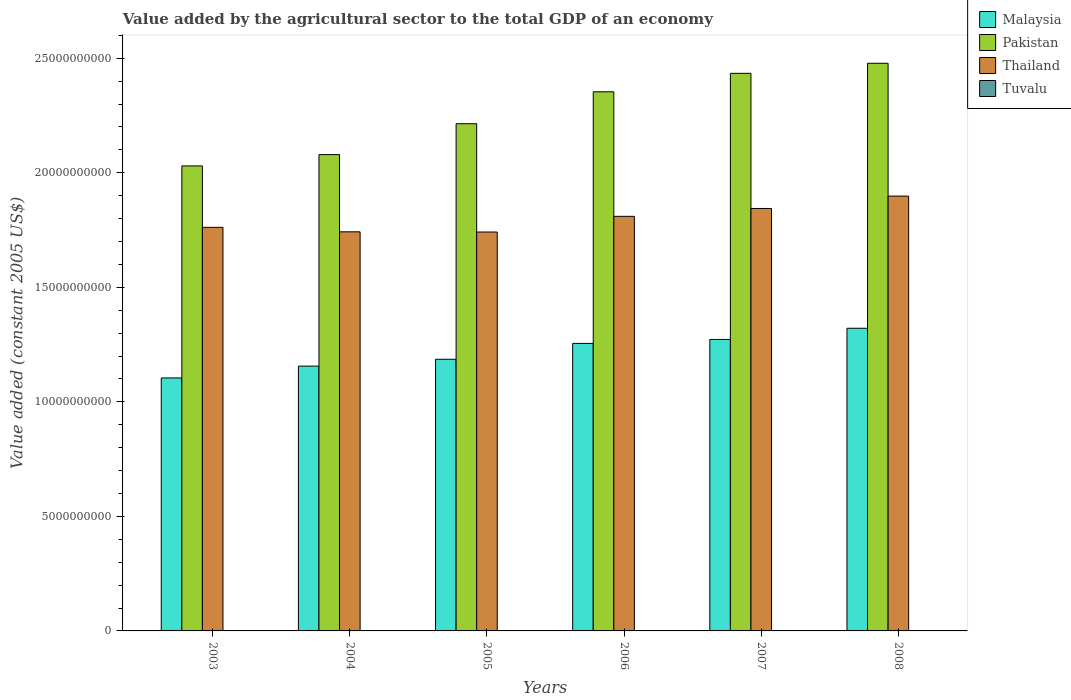How many different coloured bars are there?
Offer a terse response. 4. How many groups of bars are there?
Your answer should be very brief. 6. Are the number of bars per tick equal to the number of legend labels?
Offer a very short reply. Yes. What is the value added by the agricultural sector in Pakistan in 2005?
Make the answer very short. 2.21e+1. Across all years, what is the maximum value added by the agricultural sector in Thailand?
Give a very brief answer. 1.90e+1. Across all years, what is the minimum value added by the agricultural sector in Pakistan?
Offer a terse response. 2.03e+1. In which year was the value added by the agricultural sector in Thailand maximum?
Your response must be concise. 2008. In which year was the value added by the agricultural sector in Malaysia minimum?
Your answer should be compact. 2003. What is the total value added by the agricultural sector in Thailand in the graph?
Keep it short and to the point. 1.08e+11. What is the difference between the value added by the agricultural sector in Tuvalu in 2003 and that in 2006?
Your answer should be compact. -7.79e+05. What is the difference between the value added by the agricultural sector in Tuvalu in 2007 and the value added by the agricultural sector in Pakistan in 2005?
Offer a terse response. -2.21e+1. What is the average value added by the agricultural sector in Malaysia per year?
Keep it short and to the point. 1.22e+1. In the year 2005, what is the difference between the value added by the agricultural sector in Pakistan and value added by the agricultural sector in Tuvalu?
Your response must be concise. 2.21e+1. In how many years, is the value added by the agricultural sector in Tuvalu greater than 13000000000 US$?
Ensure brevity in your answer.  0. What is the ratio of the value added by the agricultural sector in Tuvalu in 2006 to that in 2008?
Your answer should be compact. 0.98. What is the difference between the highest and the second highest value added by the agricultural sector in Malaysia?
Your answer should be compact. 4.88e+08. What is the difference between the highest and the lowest value added by the agricultural sector in Malaysia?
Provide a succinct answer. 2.17e+09. In how many years, is the value added by the agricultural sector in Tuvalu greater than the average value added by the agricultural sector in Tuvalu taken over all years?
Give a very brief answer. 3. Is the sum of the value added by the agricultural sector in Thailand in 2003 and 2008 greater than the maximum value added by the agricultural sector in Pakistan across all years?
Give a very brief answer. Yes. What does the 1st bar from the left in 2005 represents?
Offer a very short reply. Malaysia. What does the 4th bar from the right in 2005 represents?
Your answer should be compact. Malaysia. Is it the case that in every year, the sum of the value added by the agricultural sector in Malaysia and value added by the agricultural sector in Tuvalu is greater than the value added by the agricultural sector in Thailand?
Keep it short and to the point. No. Are all the bars in the graph horizontal?
Provide a succinct answer. No. Does the graph contain any zero values?
Provide a short and direct response. No. Does the graph contain grids?
Offer a very short reply. No. What is the title of the graph?
Offer a very short reply. Value added by the agricultural sector to the total GDP of an economy. Does "Ecuador" appear as one of the legend labels in the graph?
Give a very brief answer. No. What is the label or title of the X-axis?
Give a very brief answer. Years. What is the label or title of the Y-axis?
Provide a short and direct response. Value added (constant 2005 US$). What is the Value added (constant 2005 US$) in Malaysia in 2003?
Offer a terse response. 1.10e+1. What is the Value added (constant 2005 US$) of Pakistan in 2003?
Provide a succinct answer. 2.03e+1. What is the Value added (constant 2005 US$) in Thailand in 2003?
Make the answer very short. 1.76e+1. What is the Value added (constant 2005 US$) in Tuvalu in 2003?
Your response must be concise. 4.22e+06. What is the Value added (constant 2005 US$) of Malaysia in 2004?
Your answer should be compact. 1.16e+1. What is the Value added (constant 2005 US$) of Pakistan in 2004?
Provide a short and direct response. 2.08e+1. What is the Value added (constant 2005 US$) in Thailand in 2004?
Your answer should be very brief. 1.74e+1. What is the Value added (constant 2005 US$) of Tuvalu in 2004?
Provide a succinct answer. 4.41e+06. What is the Value added (constant 2005 US$) in Malaysia in 2005?
Your answer should be compact. 1.19e+1. What is the Value added (constant 2005 US$) of Pakistan in 2005?
Your answer should be very brief. 2.21e+1. What is the Value added (constant 2005 US$) in Thailand in 2005?
Ensure brevity in your answer.  1.74e+1. What is the Value added (constant 2005 US$) of Tuvalu in 2005?
Give a very brief answer. 4.45e+06. What is the Value added (constant 2005 US$) in Malaysia in 2006?
Provide a short and direct response. 1.26e+1. What is the Value added (constant 2005 US$) in Pakistan in 2006?
Your answer should be very brief. 2.35e+1. What is the Value added (constant 2005 US$) of Thailand in 2006?
Give a very brief answer. 1.81e+1. What is the Value added (constant 2005 US$) in Tuvalu in 2006?
Your answer should be compact. 5.00e+06. What is the Value added (constant 2005 US$) in Malaysia in 2007?
Provide a short and direct response. 1.27e+1. What is the Value added (constant 2005 US$) of Pakistan in 2007?
Your answer should be very brief. 2.43e+1. What is the Value added (constant 2005 US$) in Thailand in 2007?
Offer a very short reply. 1.84e+1. What is the Value added (constant 2005 US$) in Tuvalu in 2007?
Your response must be concise. 5.06e+06. What is the Value added (constant 2005 US$) of Malaysia in 2008?
Provide a short and direct response. 1.32e+1. What is the Value added (constant 2005 US$) of Pakistan in 2008?
Provide a succinct answer. 2.48e+1. What is the Value added (constant 2005 US$) of Thailand in 2008?
Your response must be concise. 1.90e+1. What is the Value added (constant 2005 US$) in Tuvalu in 2008?
Your answer should be compact. 5.10e+06. Across all years, what is the maximum Value added (constant 2005 US$) of Malaysia?
Provide a succinct answer. 1.32e+1. Across all years, what is the maximum Value added (constant 2005 US$) of Pakistan?
Offer a terse response. 2.48e+1. Across all years, what is the maximum Value added (constant 2005 US$) in Thailand?
Offer a terse response. 1.90e+1. Across all years, what is the maximum Value added (constant 2005 US$) of Tuvalu?
Make the answer very short. 5.10e+06. Across all years, what is the minimum Value added (constant 2005 US$) of Malaysia?
Provide a short and direct response. 1.10e+1. Across all years, what is the minimum Value added (constant 2005 US$) in Pakistan?
Your answer should be compact. 2.03e+1. Across all years, what is the minimum Value added (constant 2005 US$) of Thailand?
Ensure brevity in your answer.  1.74e+1. Across all years, what is the minimum Value added (constant 2005 US$) in Tuvalu?
Your response must be concise. 4.22e+06. What is the total Value added (constant 2005 US$) in Malaysia in the graph?
Your answer should be very brief. 7.29e+1. What is the total Value added (constant 2005 US$) of Pakistan in the graph?
Your answer should be compact. 1.36e+11. What is the total Value added (constant 2005 US$) of Thailand in the graph?
Your answer should be very brief. 1.08e+11. What is the total Value added (constant 2005 US$) of Tuvalu in the graph?
Offer a very short reply. 2.82e+07. What is the difference between the Value added (constant 2005 US$) of Malaysia in 2003 and that in 2004?
Ensure brevity in your answer.  -5.16e+08. What is the difference between the Value added (constant 2005 US$) of Pakistan in 2003 and that in 2004?
Keep it short and to the point. -4.94e+08. What is the difference between the Value added (constant 2005 US$) in Thailand in 2003 and that in 2004?
Provide a succinct answer. 1.96e+08. What is the difference between the Value added (constant 2005 US$) in Tuvalu in 2003 and that in 2004?
Offer a terse response. -1.89e+05. What is the difference between the Value added (constant 2005 US$) of Malaysia in 2003 and that in 2005?
Your answer should be very brief. -8.16e+08. What is the difference between the Value added (constant 2005 US$) in Pakistan in 2003 and that in 2005?
Ensure brevity in your answer.  -1.84e+09. What is the difference between the Value added (constant 2005 US$) of Thailand in 2003 and that in 2005?
Provide a short and direct response. 2.05e+08. What is the difference between the Value added (constant 2005 US$) in Tuvalu in 2003 and that in 2005?
Provide a succinct answer. -2.29e+05. What is the difference between the Value added (constant 2005 US$) of Malaysia in 2003 and that in 2006?
Provide a succinct answer. -1.51e+09. What is the difference between the Value added (constant 2005 US$) in Pakistan in 2003 and that in 2006?
Offer a terse response. -3.24e+09. What is the difference between the Value added (constant 2005 US$) of Thailand in 2003 and that in 2006?
Make the answer very short. -4.80e+08. What is the difference between the Value added (constant 2005 US$) in Tuvalu in 2003 and that in 2006?
Provide a succinct answer. -7.79e+05. What is the difference between the Value added (constant 2005 US$) in Malaysia in 2003 and that in 2007?
Keep it short and to the point. -1.68e+09. What is the difference between the Value added (constant 2005 US$) of Pakistan in 2003 and that in 2007?
Provide a succinct answer. -4.04e+09. What is the difference between the Value added (constant 2005 US$) in Thailand in 2003 and that in 2007?
Provide a short and direct response. -8.23e+08. What is the difference between the Value added (constant 2005 US$) of Tuvalu in 2003 and that in 2007?
Make the answer very short. -8.35e+05. What is the difference between the Value added (constant 2005 US$) of Malaysia in 2003 and that in 2008?
Give a very brief answer. -2.17e+09. What is the difference between the Value added (constant 2005 US$) in Pakistan in 2003 and that in 2008?
Offer a terse response. -4.48e+09. What is the difference between the Value added (constant 2005 US$) in Thailand in 2003 and that in 2008?
Offer a very short reply. -1.36e+09. What is the difference between the Value added (constant 2005 US$) of Tuvalu in 2003 and that in 2008?
Ensure brevity in your answer.  -8.72e+05. What is the difference between the Value added (constant 2005 US$) in Malaysia in 2004 and that in 2005?
Make the answer very short. -3.00e+08. What is the difference between the Value added (constant 2005 US$) in Pakistan in 2004 and that in 2005?
Offer a very short reply. -1.35e+09. What is the difference between the Value added (constant 2005 US$) of Thailand in 2004 and that in 2005?
Your response must be concise. 8.94e+06. What is the difference between the Value added (constant 2005 US$) of Tuvalu in 2004 and that in 2005?
Your answer should be very brief. -3.93e+04. What is the difference between the Value added (constant 2005 US$) of Malaysia in 2004 and that in 2006?
Provide a succinct answer. -9.92e+08. What is the difference between the Value added (constant 2005 US$) in Pakistan in 2004 and that in 2006?
Your response must be concise. -2.74e+09. What is the difference between the Value added (constant 2005 US$) in Thailand in 2004 and that in 2006?
Provide a short and direct response. -6.76e+08. What is the difference between the Value added (constant 2005 US$) of Tuvalu in 2004 and that in 2006?
Offer a terse response. -5.90e+05. What is the difference between the Value added (constant 2005 US$) in Malaysia in 2004 and that in 2007?
Give a very brief answer. -1.16e+09. What is the difference between the Value added (constant 2005 US$) in Pakistan in 2004 and that in 2007?
Your answer should be very brief. -3.55e+09. What is the difference between the Value added (constant 2005 US$) of Thailand in 2004 and that in 2007?
Keep it short and to the point. -1.02e+09. What is the difference between the Value added (constant 2005 US$) of Tuvalu in 2004 and that in 2007?
Your answer should be very brief. -6.46e+05. What is the difference between the Value added (constant 2005 US$) of Malaysia in 2004 and that in 2008?
Make the answer very short. -1.65e+09. What is the difference between the Value added (constant 2005 US$) in Pakistan in 2004 and that in 2008?
Ensure brevity in your answer.  -3.99e+09. What is the difference between the Value added (constant 2005 US$) in Thailand in 2004 and that in 2008?
Offer a very short reply. -1.56e+09. What is the difference between the Value added (constant 2005 US$) in Tuvalu in 2004 and that in 2008?
Your answer should be very brief. -6.82e+05. What is the difference between the Value added (constant 2005 US$) of Malaysia in 2005 and that in 2006?
Offer a very short reply. -6.92e+08. What is the difference between the Value added (constant 2005 US$) of Pakistan in 2005 and that in 2006?
Offer a very short reply. -1.39e+09. What is the difference between the Value added (constant 2005 US$) of Thailand in 2005 and that in 2006?
Your answer should be compact. -6.85e+08. What is the difference between the Value added (constant 2005 US$) in Tuvalu in 2005 and that in 2006?
Ensure brevity in your answer.  -5.51e+05. What is the difference between the Value added (constant 2005 US$) in Malaysia in 2005 and that in 2007?
Provide a succinct answer. -8.65e+08. What is the difference between the Value added (constant 2005 US$) in Pakistan in 2005 and that in 2007?
Give a very brief answer. -2.20e+09. What is the difference between the Value added (constant 2005 US$) of Thailand in 2005 and that in 2007?
Your response must be concise. -1.03e+09. What is the difference between the Value added (constant 2005 US$) in Tuvalu in 2005 and that in 2007?
Your response must be concise. -6.06e+05. What is the difference between the Value added (constant 2005 US$) in Malaysia in 2005 and that in 2008?
Make the answer very short. -1.35e+09. What is the difference between the Value added (constant 2005 US$) of Pakistan in 2005 and that in 2008?
Offer a very short reply. -2.64e+09. What is the difference between the Value added (constant 2005 US$) of Thailand in 2005 and that in 2008?
Give a very brief answer. -1.57e+09. What is the difference between the Value added (constant 2005 US$) in Tuvalu in 2005 and that in 2008?
Ensure brevity in your answer.  -6.43e+05. What is the difference between the Value added (constant 2005 US$) in Malaysia in 2006 and that in 2007?
Provide a short and direct response. -1.73e+08. What is the difference between the Value added (constant 2005 US$) of Pakistan in 2006 and that in 2007?
Your answer should be very brief. -8.06e+08. What is the difference between the Value added (constant 2005 US$) of Thailand in 2006 and that in 2007?
Your answer should be compact. -3.43e+08. What is the difference between the Value added (constant 2005 US$) of Tuvalu in 2006 and that in 2007?
Your answer should be compact. -5.57e+04. What is the difference between the Value added (constant 2005 US$) of Malaysia in 2006 and that in 2008?
Give a very brief answer. -6.61e+08. What is the difference between the Value added (constant 2005 US$) in Pakistan in 2006 and that in 2008?
Your response must be concise. -1.25e+09. What is the difference between the Value added (constant 2005 US$) of Thailand in 2006 and that in 2008?
Your answer should be compact. -8.84e+08. What is the difference between the Value added (constant 2005 US$) in Tuvalu in 2006 and that in 2008?
Offer a very short reply. -9.24e+04. What is the difference between the Value added (constant 2005 US$) of Malaysia in 2007 and that in 2008?
Your response must be concise. -4.88e+08. What is the difference between the Value added (constant 2005 US$) in Pakistan in 2007 and that in 2008?
Give a very brief answer. -4.40e+08. What is the difference between the Value added (constant 2005 US$) of Thailand in 2007 and that in 2008?
Make the answer very short. -5.41e+08. What is the difference between the Value added (constant 2005 US$) in Tuvalu in 2007 and that in 2008?
Make the answer very short. -3.67e+04. What is the difference between the Value added (constant 2005 US$) in Malaysia in 2003 and the Value added (constant 2005 US$) in Pakistan in 2004?
Give a very brief answer. -9.75e+09. What is the difference between the Value added (constant 2005 US$) in Malaysia in 2003 and the Value added (constant 2005 US$) in Thailand in 2004?
Make the answer very short. -6.38e+09. What is the difference between the Value added (constant 2005 US$) of Malaysia in 2003 and the Value added (constant 2005 US$) of Tuvalu in 2004?
Make the answer very short. 1.10e+1. What is the difference between the Value added (constant 2005 US$) in Pakistan in 2003 and the Value added (constant 2005 US$) in Thailand in 2004?
Offer a terse response. 2.88e+09. What is the difference between the Value added (constant 2005 US$) in Pakistan in 2003 and the Value added (constant 2005 US$) in Tuvalu in 2004?
Your answer should be compact. 2.03e+1. What is the difference between the Value added (constant 2005 US$) in Thailand in 2003 and the Value added (constant 2005 US$) in Tuvalu in 2004?
Give a very brief answer. 1.76e+1. What is the difference between the Value added (constant 2005 US$) in Malaysia in 2003 and the Value added (constant 2005 US$) in Pakistan in 2005?
Your answer should be compact. -1.11e+1. What is the difference between the Value added (constant 2005 US$) of Malaysia in 2003 and the Value added (constant 2005 US$) of Thailand in 2005?
Your answer should be very brief. -6.37e+09. What is the difference between the Value added (constant 2005 US$) in Malaysia in 2003 and the Value added (constant 2005 US$) in Tuvalu in 2005?
Give a very brief answer. 1.10e+1. What is the difference between the Value added (constant 2005 US$) of Pakistan in 2003 and the Value added (constant 2005 US$) of Thailand in 2005?
Your answer should be compact. 2.89e+09. What is the difference between the Value added (constant 2005 US$) of Pakistan in 2003 and the Value added (constant 2005 US$) of Tuvalu in 2005?
Provide a short and direct response. 2.03e+1. What is the difference between the Value added (constant 2005 US$) of Thailand in 2003 and the Value added (constant 2005 US$) of Tuvalu in 2005?
Provide a succinct answer. 1.76e+1. What is the difference between the Value added (constant 2005 US$) of Malaysia in 2003 and the Value added (constant 2005 US$) of Pakistan in 2006?
Your response must be concise. -1.25e+1. What is the difference between the Value added (constant 2005 US$) in Malaysia in 2003 and the Value added (constant 2005 US$) in Thailand in 2006?
Make the answer very short. -7.06e+09. What is the difference between the Value added (constant 2005 US$) in Malaysia in 2003 and the Value added (constant 2005 US$) in Tuvalu in 2006?
Provide a short and direct response. 1.10e+1. What is the difference between the Value added (constant 2005 US$) of Pakistan in 2003 and the Value added (constant 2005 US$) of Thailand in 2006?
Your answer should be compact. 2.20e+09. What is the difference between the Value added (constant 2005 US$) in Pakistan in 2003 and the Value added (constant 2005 US$) in Tuvalu in 2006?
Provide a succinct answer. 2.03e+1. What is the difference between the Value added (constant 2005 US$) of Thailand in 2003 and the Value added (constant 2005 US$) of Tuvalu in 2006?
Ensure brevity in your answer.  1.76e+1. What is the difference between the Value added (constant 2005 US$) of Malaysia in 2003 and the Value added (constant 2005 US$) of Pakistan in 2007?
Make the answer very short. -1.33e+1. What is the difference between the Value added (constant 2005 US$) in Malaysia in 2003 and the Value added (constant 2005 US$) in Thailand in 2007?
Your response must be concise. -7.40e+09. What is the difference between the Value added (constant 2005 US$) of Malaysia in 2003 and the Value added (constant 2005 US$) of Tuvalu in 2007?
Your response must be concise. 1.10e+1. What is the difference between the Value added (constant 2005 US$) in Pakistan in 2003 and the Value added (constant 2005 US$) in Thailand in 2007?
Make the answer very short. 1.86e+09. What is the difference between the Value added (constant 2005 US$) in Pakistan in 2003 and the Value added (constant 2005 US$) in Tuvalu in 2007?
Your response must be concise. 2.03e+1. What is the difference between the Value added (constant 2005 US$) of Thailand in 2003 and the Value added (constant 2005 US$) of Tuvalu in 2007?
Your answer should be very brief. 1.76e+1. What is the difference between the Value added (constant 2005 US$) in Malaysia in 2003 and the Value added (constant 2005 US$) in Pakistan in 2008?
Give a very brief answer. -1.37e+1. What is the difference between the Value added (constant 2005 US$) of Malaysia in 2003 and the Value added (constant 2005 US$) of Thailand in 2008?
Keep it short and to the point. -7.94e+09. What is the difference between the Value added (constant 2005 US$) in Malaysia in 2003 and the Value added (constant 2005 US$) in Tuvalu in 2008?
Offer a terse response. 1.10e+1. What is the difference between the Value added (constant 2005 US$) of Pakistan in 2003 and the Value added (constant 2005 US$) of Thailand in 2008?
Offer a very short reply. 1.32e+09. What is the difference between the Value added (constant 2005 US$) of Pakistan in 2003 and the Value added (constant 2005 US$) of Tuvalu in 2008?
Keep it short and to the point. 2.03e+1. What is the difference between the Value added (constant 2005 US$) in Thailand in 2003 and the Value added (constant 2005 US$) in Tuvalu in 2008?
Ensure brevity in your answer.  1.76e+1. What is the difference between the Value added (constant 2005 US$) of Malaysia in 2004 and the Value added (constant 2005 US$) of Pakistan in 2005?
Keep it short and to the point. -1.06e+1. What is the difference between the Value added (constant 2005 US$) of Malaysia in 2004 and the Value added (constant 2005 US$) of Thailand in 2005?
Provide a short and direct response. -5.85e+09. What is the difference between the Value added (constant 2005 US$) in Malaysia in 2004 and the Value added (constant 2005 US$) in Tuvalu in 2005?
Provide a succinct answer. 1.16e+1. What is the difference between the Value added (constant 2005 US$) of Pakistan in 2004 and the Value added (constant 2005 US$) of Thailand in 2005?
Ensure brevity in your answer.  3.38e+09. What is the difference between the Value added (constant 2005 US$) of Pakistan in 2004 and the Value added (constant 2005 US$) of Tuvalu in 2005?
Offer a very short reply. 2.08e+1. What is the difference between the Value added (constant 2005 US$) in Thailand in 2004 and the Value added (constant 2005 US$) in Tuvalu in 2005?
Give a very brief answer. 1.74e+1. What is the difference between the Value added (constant 2005 US$) of Malaysia in 2004 and the Value added (constant 2005 US$) of Pakistan in 2006?
Offer a terse response. -1.20e+1. What is the difference between the Value added (constant 2005 US$) in Malaysia in 2004 and the Value added (constant 2005 US$) in Thailand in 2006?
Ensure brevity in your answer.  -6.54e+09. What is the difference between the Value added (constant 2005 US$) of Malaysia in 2004 and the Value added (constant 2005 US$) of Tuvalu in 2006?
Your answer should be very brief. 1.16e+1. What is the difference between the Value added (constant 2005 US$) in Pakistan in 2004 and the Value added (constant 2005 US$) in Thailand in 2006?
Provide a short and direct response. 2.69e+09. What is the difference between the Value added (constant 2005 US$) in Pakistan in 2004 and the Value added (constant 2005 US$) in Tuvalu in 2006?
Give a very brief answer. 2.08e+1. What is the difference between the Value added (constant 2005 US$) in Thailand in 2004 and the Value added (constant 2005 US$) in Tuvalu in 2006?
Your response must be concise. 1.74e+1. What is the difference between the Value added (constant 2005 US$) of Malaysia in 2004 and the Value added (constant 2005 US$) of Pakistan in 2007?
Give a very brief answer. -1.28e+1. What is the difference between the Value added (constant 2005 US$) of Malaysia in 2004 and the Value added (constant 2005 US$) of Thailand in 2007?
Give a very brief answer. -6.88e+09. What is the difference between the Value added (constant 2005 US$) in Malaysia in 2004 and the Value added (constant 2005 US$) in Tuvalu in 2007?
Give a very brief answer. 1.16e+1. What is the difference between the Value added (constant 2005 US$) in Pakistan in 2004 and the Value added (constant 2005 US$) in Thailand in 2007?
Provide a succinct answer. 2.35e+09. What is the difference between the Value added (constant 2005 US$) in Pakistan in 2004 and the Value added (constant 2005 US$) in Tuvalu in 2007?
Your response must be concise. 2.08e+1. What is the difference between the Value added (constant 2005 US$) of Thailand in 2004 and the Value added (constant 2005 US$) of Tuvalu in 2007?
Ensure brevity in your answer.  1.74e+1. What is the difference between the Value added (constant 2005 US$) of Malaysia in 2004 and the Value added (constant 2005 US$) of Pakistan in 2008?
Give a very brief answer. -1.32e+1. What is the difference between the Value added (constant 2005 US$) in Malaysia in 2004 and the Value added (constant 2005 US$) in Thailand in 2008?
Provide a short and direct response. -7.42e+09. What is the difference between the Value added (constant 2005 US$) of Malaysia in 2004 and the Value added (constant 2005 US$) of Tuvalu in 2008?
Your answer should be compact. 1.16e+1. What is the difference between the Value added (constant 2005 US$) of Pakistan in 2004 and the Value added (constant 2005 US$) of Thailand in 2008?
Give a very brief answer. 1.81e+09. What is the difference between the Value added (constant 2005 US$) of Pakistan in 2004 and the Value added (constant 2005 US$) of Tuvalu in 2008?
Ensure brevity in your answer.  2.08e+1. What is the difference between the Value added (constant 2005 US$) in Thailand in 2004 and the Value added (constant 2005 US$) in Tuvalu in 2008?
Provide a succinct answer. 1.74e+1. What is the difference between the Value added (constant 2005 US$) of Malaysia in 2005 and the Value added (constant 2005 US$) of Pakistan in 2006?
Make the answer very short. -1.17e+1. What is the difference between the Value added (constant 2005 US$) in Malaysia in 2005 and the Value added (constant 2005 US$) in Thailand in 2006?
Give a very brief answer. -6.24e+09. What is the difference between the Value added (constant 2005 US$) in Malaysia in 2005 and the Value added (constant 2005 US$) in Tuvalu in 2006?
Keep it short and to the point. 1.19e+1. What is the difference between the Value added (constant 2005 US$) in Pakistan in 2005 and the Value added (constant 2005 US$) in Thailand in 2006?
Your response must be concise. 4.04e+09. What is the difference between the Value added (constant 2005 US$) of Pakistan in 2005 and the Value added (constant 2005 US$) of Tuvalu in 2006?
Your response must be concise. 2.21e+1. What is the difference between the Value added (constant 2005 US$) in Thailand in 2005 and the Value added (constant 2005 US$) in Tuvalu in 2006?
Provide a short and direct response. 1.74e+1. What is the difference between the Value added (constant 2005 US$) in Malaysia in 2005 and the Value added (constant 2005 US$) in Pakistan in 2007?
Offer a very short reply. -1.25e+1. What is the difference between the Value added (constant 2005 US$) of Malaysia in 2005 and the Value added (constant 2005 US$) of Thailand in 2007?
Offer a very short reply. -6.58e+09. What is the difference between the Value added (constant 2005 US$) in Malaysia in 2005 and the Value added (constant 2005 US$) in Tuvalu in 2007?
Your response must be concise. 1.19e+1. What is the difference between the Value added (constant 2005 US$) in Pakistan in 2005 and the Value added (constant 2005 US$) in Thailand in 2007?
Offer a terse response. 3.70e+09. What is the difference between the Value added (constant 2005 US$) in Pakistan in 2005 and the Value added (constant 2005 US$) in Tuvalu in 2007?
Offer a terse response. 2.21e+1. What is the difference between the Value added (constant 2005 US$) of Thailand in 2005 and the Value added (constant 2005 US$) of Tuvalu in 2007?
Provide a succinct answer. 1.74e+1. What is the difference between the Value added (constant 2005 US$) of Malaysia in 2005 and the Value added (constant 2005 US$) of Pakistan in 2008?
Your answer should be very brief. -1.29e+1. What is the difference between the Value added (constant 2005 US$) in Malaysia in 2005 and the Value added (constant 2005 US$) in Thailand in 2008?
Keep it short and to the point. -7.12e+09. What is the difference between the Value added (constant 2005 US$) of Malaysia in 2005 and the Value added (constant 2005 US$) of Tuvalu in 2008?
Offer a terse response. 1.19e+1. What is the difference between the Value added (constant 2005 US$) of Pakistan in 2005 and the Value added (constant 2005 US$) of Thailand in 2008?
Offer a terse response. 3.16e+09. What is the difference between the Value added (constant 2005 US$) of Pakistan in 2005 and the Value added (constant 2005 US$) of Tuvalu in 2008?
Offer a terse response. 2.21e+1. What is the difference between the Value added (constant 2005 US$) of Thailand in 2005 and the Value added (constant 2005 US$) of Tuvalu in 2008?
Make the answer very short. 1.74e+1. What is the difference between the Value added (constant 2005 US$) in Malaysia in 2006 and the Value added (constant 2005 US$) in Pakistan in 2007?
Provide a short and direct response. -1.18e+1. What is the difference between the Value added (constant 2005 US$) in Malaysia in 2006 and the Value added (constant 2005 US$) in Thailand in 2007?
Keep it short and to the point. -5.89e+09. What is the difference between the Value added (constant 2005 US$) in Malaysia in 2006 and the Value added (constant 2005 US$) in Tuvalu in 2007?
Offer a very short reply. 1.25e+1. What is the difference between the Value added (constant 2005 US$) in Pakistan in 2006 and the Value added (constant 2005 US$) in Thailand in 2007?
Your response must be concise. 5.09e+09. What is the difference between the Value added (constant 2005 US$) of Pakistan in 2006 and the Value added (constant 2005 US$) of Tuvalu in 2007?
Your response must be concise. 2.35e+1. What is the difference between the Value added (constant 2005 US$) of Thailand in 2006 and the Value added (constant 2005 US$) of Tuvalu in 2007?
Ensure brevity in your answer.  1.81e+1. What is the difference between the Value added (constant 2005 US$) of Malaysia in 2006 and the Value added (constant 2005 US$) of Pakistan in 2008?
Ensure brevity in your answer.  -1.22e+1. What is the difference between the Value added (constant 2005 US$) of Malaysia in 2006 and the Value added (constant 2005 US$) of Thailand in 2008?
Your answer should be very brief. -6.43e+09. What is the difference between the Value added (constant 2005 US$) of Malaysia in 2006 and the Value added (constant 2005 US$) of Tuvalu in 2008?
Offer a terse response. 1.25e+1. What is the difference between the Value added (constant 2005 US$) of Pakistan in 2006 and the Value added (constant 2005 US$) of Thailand in 2008?
Your response must be concise. 4.55e+09. What is the difference between the Value added (constant 2005 US$) of Pakistan in 2006 and the Value added (constant 2005 US$) of Tuvalu in 2008?
Your answer should be compact. 2.35e+1. What is the difference between the Value added (constant 2005 US$) in Thailand in 2006 and the Value added (constant 2005 US$) in Tuvalu in 2008?
Ensure brevity in your answer.  1.81e+1. What is the difference between the Value added (constant 2005 US$) in Malaysia in 2007 and the Value added (constant 2005 US$) in Pakistan in 2008?
Make the answer very short. -1.21e+1. What is the difference between the Value added (constant 2005 US$) in Malaysia in 2007 and the Value added (constant 2005 US$) in Thailand in 2008?
Offer a very short reply. -6.26e+09. What is the difference between the Value added (constant 2005 US$) of Malaysia in 2007 and the Value added (constant 2005 US$) of Tuvalu in 2008?
Give a very brief answer. 1.27e+1. What is the difference between the Value added (constant 2005 US$) of Pakistan in 2007 and the Value added (constant 2005 US$) of Thailand in 2008?
Provide a short and direct response. 5.36e+09. What is the difference between the Value added (constant 2005 US$) in Pakistan in 2007 and the Value added (constant 2005 US$) in Tuvalu in 2008?
Give a very brief answer. 2.43e+1. What is the difference between the Value added (constant 2005 US$) of Thailand in 2007 and the Value added (constant 2005 US$) of Tuvalu in 2008?
Offer a terse response. 1.84e+1. What is the average Value added (constant 2005 US$) in Malaysia per year?
Your answer should be compact. 1.22e+1. What is the average Value added (constant 2005 US$) in Pakistan per year?
Provide a succinct answer. 2.26e+1. What is the average Value added (constant 2005 US$) of Thailand per year?
Give a very brief answer. 1.80e+1. What is the average Value added (constant 2005 US$) in Tuvalu per year?
Provide a short and direct response. 4.71e+06. In the year 2003, what is the difference between the Value added (constant 2005 US$) in Malaysia and Value added (constant 2005 US$) in Pakistan?
Give a very brief answer. -9.26e+09. In the year 2003, what is the difference between the Value added (constant 2005 US$) of Malaysia and Value added (constant 2005 US$) of Thailand?
Keep it short and to the point. -6.58e+09. In the year 2003, what is the difference between the Value added (constant 2005 US$) in Malaysia and Value added (constant 2005 US$) in Tuvalu?
Give a very brief answer. 1.10e+1. In the year 2003, what is the difference between the Value added (constant 2005 US$) in Pakistan and Value added (constant 2005 US$) in Thailand?
Offer a very short reply. 2.68e+09. In the year 2003, what is the difference between the Value added (constant 2005 US$) in Pakistan and Value added (constant 2005 US$) in Tuvalu?
Offer a very short reply. 2.03e+1. In the year 2003, what is the difference between the Value added (constant 2005 US$) in Thailand and Value added (constant 2005 US$) in Tuvalu?
Make the answer very short. 1.76e+1. In the year 2004, what is the difference between the Value added (constant 2005 US$) of Malaysia and Value added (constant 2005 US$) of Pakistan?
Provide a short and direct response. -9.23e+09. In the year 2004, what is the difference between the Value added (constant 2005 US$) of Malaysia and Value added (constant 2005 US$) of Thailand?
Give a very brief answer. -5.86e+09. In the year 2004, what is the difference between the Value added (constant 2005 US$) in Malaysia and Value added (constant 2005 US$) in Tuvalu?
Make the answer very short. 1.16e+1. In the year 2004, what is the difference between the Value added (constant 2005 US$) in Pakistan and Value added (constant 2005 US$) in Thailand?
Give a very brief answer. 3.37e+09. In the year 2004, what is the difference between the Value added (constant 2005 US$) of Pakistan and Value added (constant 2005 US$) of Tuvalu?
Offer a very short reply. 2.08e+1. In the year 2004, what is the difference between the Value added (constant 2005 US$) of Thailand and Value added (constant 2005 US$) of Tuvalu?
Keep it short and to the point. 1.74e+1. In the year 2005, what is the difference between the Value added (constant 2005 US$) of Malaysia and Value added (constant 2005 US$) of Pakistan?
Give a very brief answer. -1.03e+1. In the year 2005, what is the difference between the Value added (constant 2005 US$) in Malaysia and Value added (constant 2005 US$) in Thailand?
Your answer should be very brief. -5.55e+09. In the year 2005, what is the difference between the Value added (constant 2005 US$) in Malaysia and Value added (constant 2005 US$) in Tuvalu?
Your answer should be compact. 1.19e+1. In the year 2005, what is the difference between the Value added (constant 2005 US$) in Pakistan and Value added (constant 2005 US$) in Thailand?
Keep it short and to the point. 4.73e+09. In the year 2005, what is the difference between the Value added (constant 2005 US$) in Pakistan and Value added (constant 2005 US$) in Tuvalu?
Your answer should be compact. 2.21e+1. In the year 2005, what is the difference between the Value added (constant 2005 US$) in Thailand and Value added (constant 2005 US$) in Tuvalu?
Your response must be concise. 1.74e+1. In the year 2006, what is the difference between the Value added (constant 2005 US$) in Malaysia and Value added (constant 2005 US$) in Pakistan?
Provide a short and direct response. -1.10e+1. In the year 2006, what is the difference between the Value added (constant 2005 US$) in Malaysia and Value added (constant 2005 US$) in Thailand?
Offer a very short reply. -5.55e+09. In the year 2006, what is the difference between the Value added (constant 2005 US$) of Malaysia and Value added (constant 2005 US$) of Tuvalu?
Provide a succinct answer. 1.25e+1. In the year 2006, what is the difference between the Value added (constant 2005 US$) of Pakistan and Value added (constant 2005 US$) of Thailand?
Make the answer very short. 5.44e+09. In the year 2006, what is the difference between the Value added (constant 2005 US$) in Pakistan and Value added (constant 2005 US$) in Tuvalu?
Provide a short and direct response. 2.35e+1. In the year 2006, what is the difference between the Value added (constant 2005 US$) in Thailand and Value added (constant 2005 US$) in Tuvalu?
Offer a very short reply. 1.81e+1. In the year 2007, what is the difference between the Value added (constant 2005 US$) in Malaysia and Value added (constant 2005 US$) in Pakistan?
Provide a succinct answer. -1.16e+1. In the year 2007, what is the difference between the Value added (constant 2005 US$) in Malaysia and Value added (constant 2005 US$) in Thailand?
Offer a terse response. -5.72e+09. In the year 2007, what is the difference between the Value added (constant 2005 US$) in Malaysia and Value added (constant 2005 US$) in Tuvalu?
Ensure brevity in your answer.  1.27e+1. In the year 2007, what is the difference between the Value added (constant 2005 US$) in Pakistan and Value added (constant 2005 US$) in Thailand?
Make the answer very short. 5.90e+09. In the year 2007, what is the difference between the Value added (constant 2005 US$) in Pakistan and Value added (constant 2005 US$) in Tuvalu?
Your answer should be very brief. 2.43e+1. In the year 2007, what is the difference between the Value added (constant 2005 US$) in Thailand and Value added (constant 2005 US$) in Tuvalu?
Make the answer very short. 1.84e+1. In the year 2008, what is the difference between the Value added (constant 2005 US$) in Malaysia and Value added (constant 2005 US$) in Pakistan?
Offer a very short reply. -1.16e+1. In the year 2008, what is the difference between the Value added (constant 2005 US$) in Malaysia and Value added (constant 2005 US$) in Thailand?
Your answer should be compact. -5.77e+09. In the year 2008, what is the difference between the Value added (constant 2005 US$) of Malaysia and Value added (constant 2005 US$) of Tuvalu?
Make the answer very short. 1.32e+1. In the year 2008, what is the difference between the Value added (constant 2005 US$) of Pakistan and Value added (constant 2005 US$) of Thailand?
Your response must be concise. 5.80e+09. In the year 2008, what is the difference between the Value added (constant 2005 US$) in Pakistan and Value added (constant 2005 US$) in Tuvalu?
Your answer should be very brief. 2.48e+1. In the year 2008, what is the difference between the Value added (constant 2005 US$) in Thailand and Value added (constant 2005 US$) in Tuvalu?
Ensure brevity in your answer.  1.90e+1. What is the ratio of the Value added (constant 2005 US$) in Malaysia in 2003 to that in 2004?
Your answer should be very brief. 0.96. What is the ratio of the Value added (constant 2005 US$) in Pakistan in 2003 to that in 2004?
Provide a short and direct response. 0.98. What is the ratio of the Value added (constant 2005 US$) in Thailand in 2003 to that in 2004?
Offer a very short reply. 1.01. What is the ratio of the Value added (constant 2005 US$) in Tuvalu in 2003 to that in 2004?
Your answer should be very brief. 0.96. What is the ratio of the Value added (constant 2005 US$) in Malaysia in 2003 to that in 2005?
Your answer should be very brief. 0.93. What is the ratio of the Value added (constant 2005 US$) of Pakistan in 2003 to that in 2005?
Keep it short and to the point. 0.92. What is the ratio of the Value added (constant 2005 US$) in Thailand in 2003 to that in 2005?
Offer a terse response. 1.01. What is the ratio of the Value added (constant 2005 US$) of Tuvalu in 2003 to that in 2005?
Offer a terse response. 0.95. What is the ratio of the Value added (constant 2005 US$) of Malaysia in 2003 to that in 2006?
Offer a terse response. 0.88. What is the ratio of the Value added (constant 2005 US$) in Pakistan in 2003 to that in 2006?
Ensure brevity in your answer.  0.86. What is the ratio of the Value added (constant 2005 US$) in Thailand in 2003 to that in 2006?
Give a very brief answer. 0.97. What is the ratio of the Value added (constant 2005 US$) of Tuvalu in 2003 to that in 2006?
Offer a terse response. 0.84. What is the ratio of the Value added (constant 2005 US$) of Malaysia in 2003 to that in 2007?
Keep it short and to the point. 0.87. What is the ratio of the Value added (constant 2005 US$) of Pakistan in 2003 to that in 2007?
Give a very brief answer. 0.83. What is the ratio of the Value added (constant 2005 US$) of Thailand in 2003 to that in 2007?
Provide a succinct answer. 0.96. What is the ratio of the Value added (constant 2005 US$) of Tuvalu in 2003 to that in 2007?
Your response must be concise. 0.83. What is the ratio of the Value added (constant 2005 US$) of Malaysia in 2003 to that in 2008?
Ensure brevity in your answer.  0.84. What is the ratio of the Value added (constant 2005 US$) in Pakistan in 2003 to that in 2008?
Keep it short and to the point. 0.82. What is the ratio of the Value added (constant 2005 US$) in Thailand in 2003 to that in 2008?
Your response must be concise. 0.93. What is the ratio of the Value added (constant 2005 US$) of Tuvalu in 2003 to that in 2008?
Your answer should be compact. 0.83. What is the ratio of the Value added (constant 2005 US$) of Malaysia in 2004 to that in 2005?
Your response must be concise. 0.97. What is the ratio of the Value added (constant 2005 US$) of Pakistan in 2004 to that in 2005?
Keep it short and to the point. 0.94. What is the ratio of the Value added (constant 2005 US$) in Thailand in 2004 to that in 2005?
Your answer should be very brief. 1. What is the ratio of the Value added (constant 2005 US$) of Malaysia in 2004 to that in 2006?
Your answer should be compact. 0.92. What is the ratio of the Value added (constant 2005 US$) in Pakistan in 2004 to that in 2006?
Your answer should be very brief. 0.88. What is the ratio of the Value added (constant 2005 US$) of Thailand in 2004 to that in 2006?
Ensure brevity in your answer.  0.96. What is the ratio of the Value added (constant 2005 US$) in Tuvalu in 2004 to that in 2006?
Provide a short and direct response. 0.88. What is the ratio of the Value added (constant 2005 US$) in Malaysia in 2004 to that in 2007?
Offer a terse response. 0.91. What is the ratio of the Value added (constant 2005 US$) of Pakistan in 2004 to that in 2007?
Ensure brevity in your answer.  0.85. What is the ratio of the Value added (constant 2005 US$) of Thailand in 2004 to that in 2007?
Your answer should be compact. 0.94. What is the ratio of the Value added (constant 2005 US$) in Tuvalu in 2004 to that in 2007?
Give a very brief answer. 0.87. What is the ratio of the Value added (constant 2005 US$) of Malaysia in 2004 to that in 2008?
Provide a short and direct response. 0.87. What is the ratio of the Value added (constant 2005 US$) in Pakistan in 2004 to that in 2008?
Provide a short and direct response. 0.84. What is the ratio of the Value added (constant 2005 US$) of Thailand in 2004 to that in 2008?
Provide a short and direct response. 0.92. What is the ratio of the Value added (constant 2005 US$) in Tuvalu in 2004 to that in 2008?
Ensure brevity in your answer.  0.87. What is the ratio of the Value added (constant 2005 US$) of Malaysia in 2005 to that in 2006?
Provide a succinct answer. 0.94. What is the ratio of the Value added (constant 2005 US$) of Pakistan in 2005 to that in 2006?
Ensure brevity in your answer.  0.94. What is the ratio of the Value added (constant 2005 US$) of Thailand in 2005 to that in 2006?
Keep it short and to the point. 0.96. What is the ratio of the Value added (constant 2005 US$) of Tuvalu in 2005 to that in 2006?
Your response must be concise. 0.89. What is the ratio of the Value added (constant 2005 US$) of Malaysia in 2005 to that in 2007?
Offer a terse response. 0.93. What is the ratio of the Value added (constant 2005 US$) in Pakistan in 2005 to that in 2007?
Offer a terse response. 0.91. What is the ratio of the Value added (constant 2005 US$) of Thailand in 2005 to that in 2007?
Ensure brevity in your answer.  0.94. What is the ratio of the Value added (constant 2005 US$) of Tuvalu in 2005 to that in 2007?
Provide a short and direct response. 0.88. What is the ratio of the Value added (constant 2005 US$) in Malaysia in 2005 to that in 2008?
Provide a short and direct response. 0.9. What is the ratio of the Value added (constant 2005 US$) of Pakistan in 2005 to that in 2008?
Your response must be concise. 0.89. What is the ratio of the Value added (constant 2005 US$) of Thailand in 2005 to that in 2008?
Ensure brevity in your answer.  0.92. What is the ratio of the Value added (constant 2005 US$) in Tuvalu in 2005 to that in 2008?
Offer a very short reply. 0.87. What is the ratio of the Value added (constant 2005 US$) in Malaysia in 2006 to that in 2007?
Give a very brief answer. 0.99. What is the ratio of the Value added (constant 2005 US$) in Pakistan in 2006 to that in 2007?
Make the answer very short. 0.97. What is the ratio of the Value added (constant 2005 US$) of Thailand in 2006 to that in 2007?
Make the answer very short. 0.98. What is the ratio of the Value added (constant 2005 US$) of Malaysia in 2006 to that in 2008?
Make the answer very short. 0.95. What is the ratio of the Value added (constant 2005 US$) of Pakistan in 2006 to that in 2008?
Your response must be concise. 0.95. What is the ratio of the Value added (constant 2005 US$) of Thailand in 2006 to that in 2008?
Offer a terse response. 0.95. What is the ratio of the Value added (constant 2005 US$) in Tuvalu in 2006 to that in 2008?
Your answer should be very brief. 0.98. What is the ratio of the Value added (constant 2005 US$) in Malaysia in 2007 to that in 2008?
Your answer should be very brief. 0.96. What is the ratio of the Value added (constant 2005 US$) of Pakistan in 2007 to that in 2008?
Keep it short and to the point. 0.98. What is the ratio of the Value added (constant 2005 US$) in Thailand in 2007 to that in 2008?
Ensure brevity in your answer.  0.97. What is the difference between the highest and the second highest Value added (constant 2005 US$) of Malaysia?
Keep it short and to the point. 4.88e+08. What is the difference between the highest and the second highest Value added (constant 2005 US$) in Pakistan?
Keep it short and to the point. 4.40e+08. What is the difference between the highest and the second highest Value added (constant 2005 US$) in Thailand?
Ensure brevity in your answer.  5.41e+08. What is the difference between the highest and the second highest Value added (constant 2005 US$) of Tuvalu?
Your response must be concise. 3.67e+04. What is the difference between the highest and the lowest Value added (constant 2005 US$) in Malaysia?
Offer a very short reply. 2.17e+09. What is the difference between the highest and the lowest Value added (constant 2005 US$) of Pakistan?
Offer a terse response. 4.48e+09. What is the difference between the highest and the lowest Value added (constant 2005 US$) of Thailand?
Offer a terse response. 1.57e+09. What is the difference between the highest and the lowest Value added (constant 2005 US$) in Tuvalu?
Offer a terse response. 8.72e+05. 